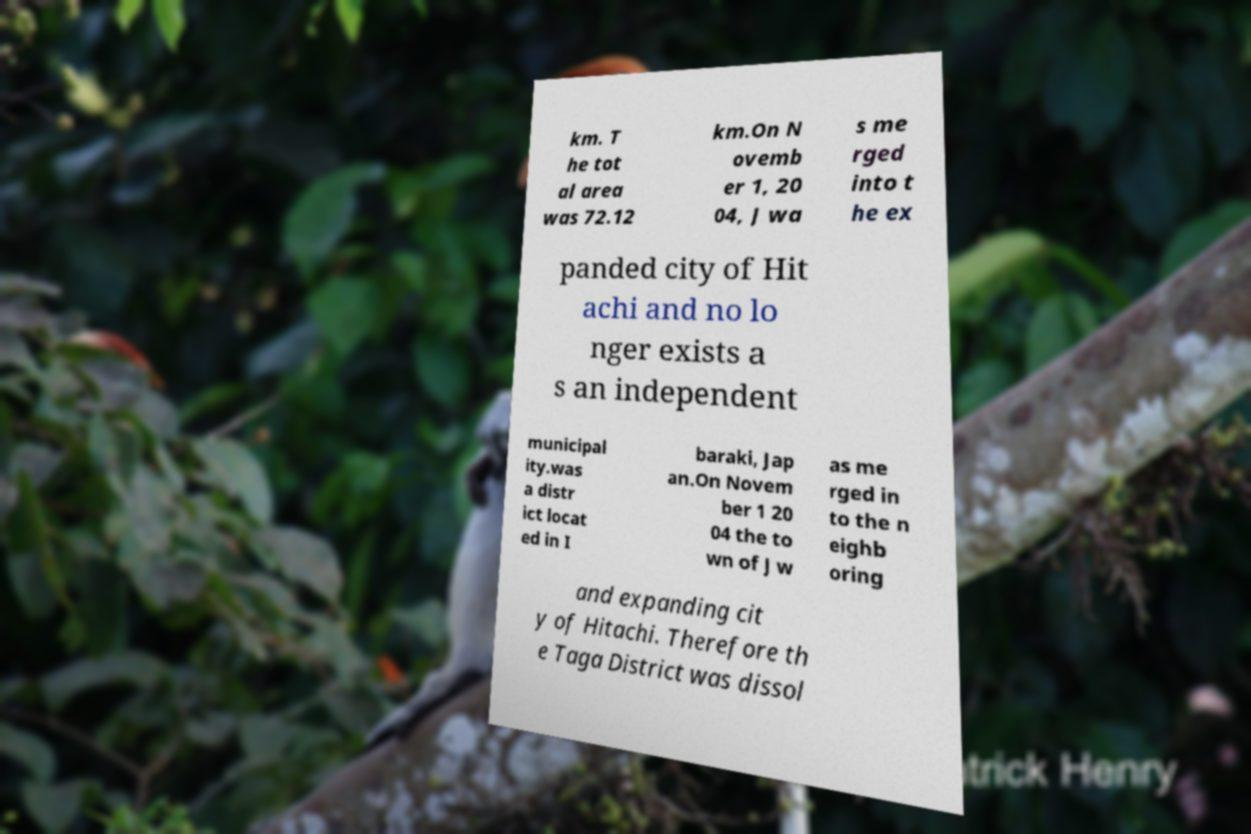Could you assist in decoding the text presented in this image and type it out clearly? km. T he tot al area was 72.12 km.On N ovemb er 1, 20 04, J wa s me rged into t he ex panded city of Hit achi and no lo nger exists a s an independent municipal ity.was a distr ict locat ed in I baraki, Jap an.On Novem ber 1 20 04 the to wn of J w as me rged in to the n eighb oring and expanding cit y of Hitachi. Therefore th e Taga District was dissol 